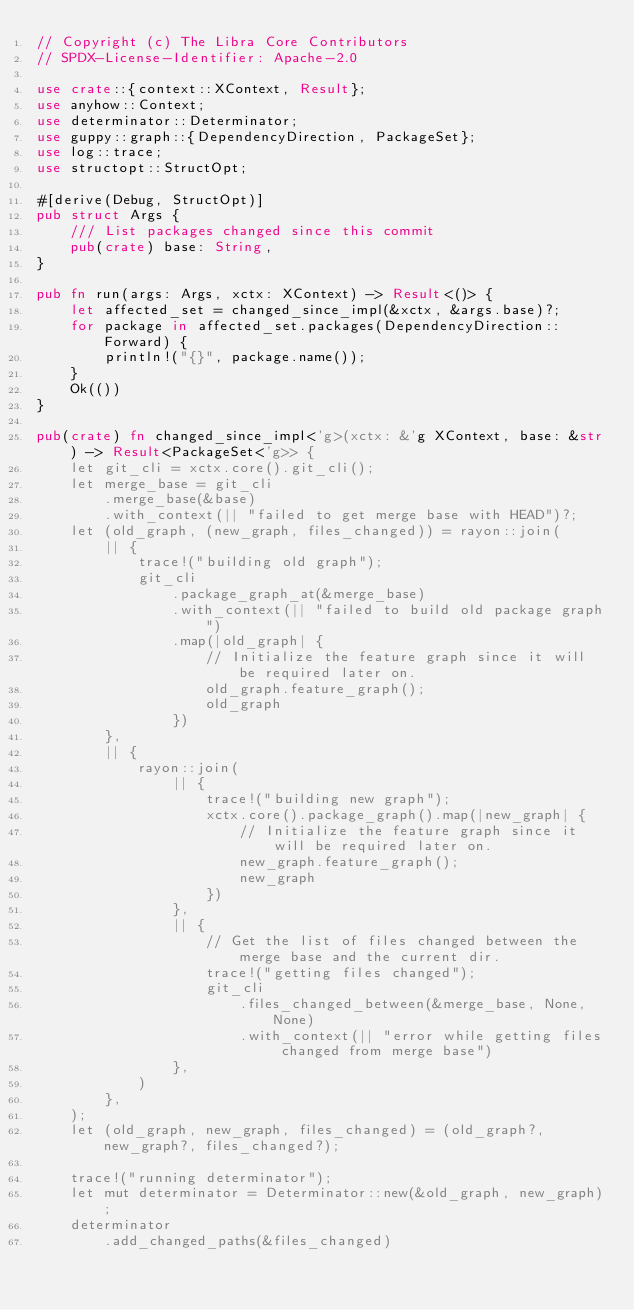<code> <loc_0><loc_0><loc_500><loc_500><_Rust_>// Copyright (c) The Libra Core Contributors
// SPDX-License-Identifier: Apache-2.0

use crate::{context::XContext, Result};
use anyhow::Context;
use determinator::Determinator;
use guppy::graph::{DependencyDirection, PackageSet};
use log::trace;
use structopt::StructOpt;

#[derive(Debug, StructOpt)]
pub struct Args {
    /// List packages changed since this commit
    pub(crate) base: String,
}

pub fn run(args: Args, xctx: XContext) -> Result<()> {
    let affected_set = changed_since_impl(&xctx, &args.base)?;
    for package in affected_set.packages(DependencyDirection::Forward) {
        println!("{}", package.name());
    }
    Ok(())
}

pub(crate) fn changed_since_impl<'g>(xctx: &'g XContext, base: &str) -> Result<PackageSet<'g>> {
    let git_cli = xctx.core().git_cli();
    let merge_base = git_cli
        .merge_base(&base)
        .with_context(|| "failed to get merge base with HEAD")?;
    let (old_graph, (new_graph, files_changed)) = rayon::join(
        || {
            trace!("building old graph");
            git_cli
                .package_graph_at(&merge_base)
                .with_context(|| "failed to build old package graph")
                .map(|old_graph| {
                    // Initialize the feature graph since it will be required later on.
                    old_graph.feature_graph();
                    old_graph
                })
        },
        || {
            rayon::join(
                || {
                    trace!("building new graph");
                    xctx.core().package_graph().map(|new_graph| {
                        // Initialize the feature graph since it will be required later on.
                        new_graph.feature_graph();
                        new_graph
                    })
                },
                || {
                    // Get the list of files changed between the merge base and the current dir.
                    trace!("getting files changed");
                    git_cli
                        .files_changed_between(&merge_base, None, None)
                        .with_context(|| "error while getting files changed from merge base")
                },
            )
        },
    );
    let (old_graph, new_graph, files_changed) = (old_graph?, new_graph?, files_changed?);

    trace!("running determinator");
    let mut determinator = Determinator::new(&old_graph, new_graph);
    determinator
        .add_changed_paths(&files_changed)</code> 